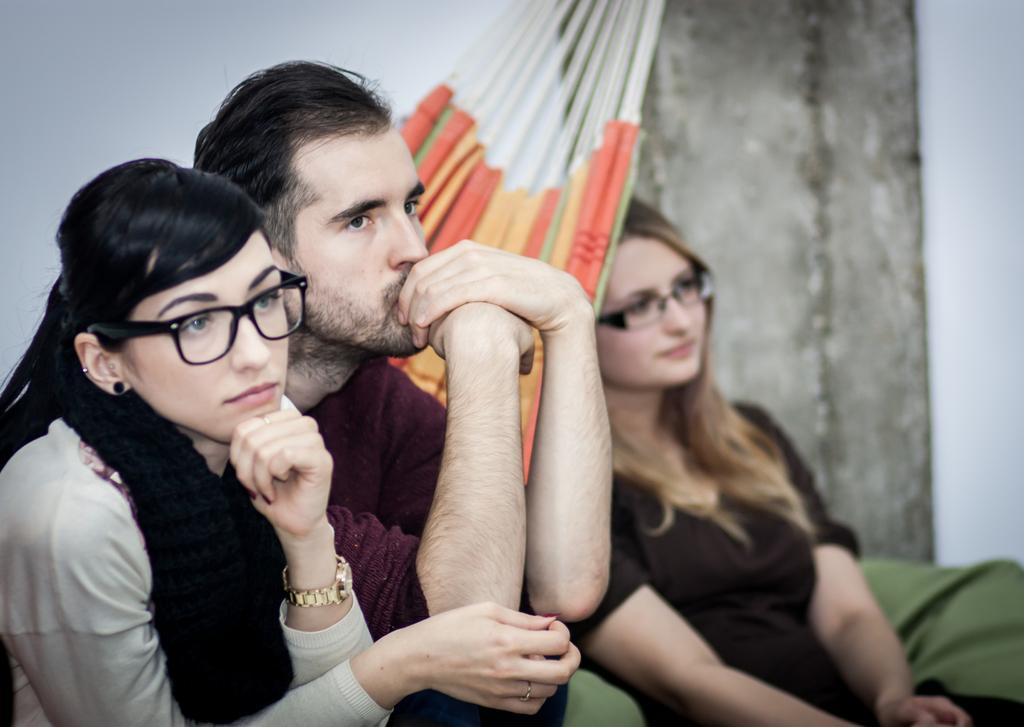How many people are in the image? There are two women and one man in the image. What is the man doing in the image? The man is sitting. What color is the man's t-shirt? The man is wearing a pink t-shirt. What colors are the women's dresses? One woman is wearing a white dress, and the other woman is wearing a brown dress. What property is the man trying to push in the image? There is no property or pushing action depicted in the image. 